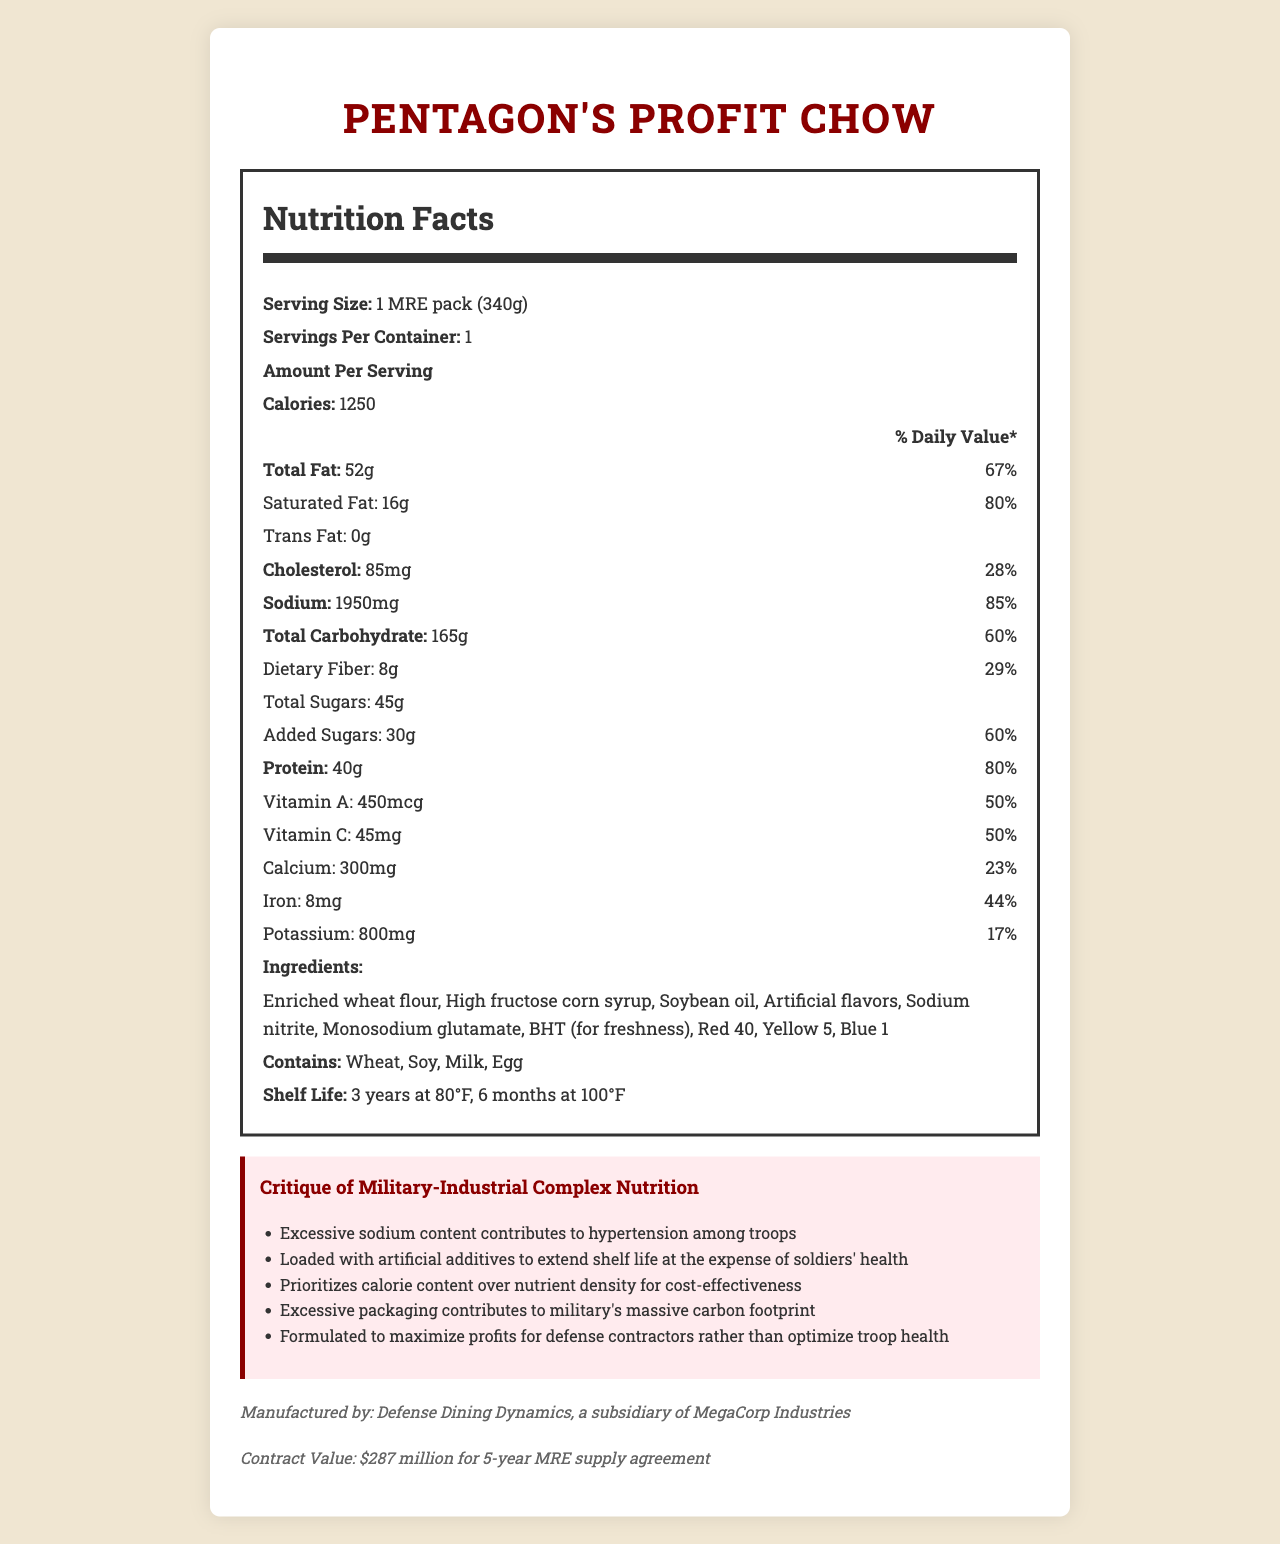what is the serving size for "Pentagon's Profit Chow"? The serving size mentioned in the document is "1 MRE pack (340g)".
Answer: 1 MRE pack (340g) how many calories are in one serving of this MRE? The document states that one serving contains 1250 calories.
Answer: 1250 what is the daily value percentage for saturated fat in one serving? The saturated fat daily value percentage for one serving is listed as 80%.
Answer: 80% list three artificial additives mentioned in the ingredients. The document includes Red 40, Yellow 5, and Blue 1 as artificial additives.
Answer: Red 40, Yellow 5, Blue 1 what is the shelf life of the MRE at 100°F? The MRE's shelf life at 100°F is stated to be 6 months.
Answer: 6 months what is the sodium content in one serving of this MRE? A. 1500 mg B. 2000 mg C. 1950 mg D. 2100 mg The sodium content in one serving is specified as 1950 mg.
Answer: C. 1950 mg which of the following is NOT an allergen in the MRE? 1. Wheat 2. Soy 3. Peanuts 4. Milk The allergens listed in the document are Wheat, Soy, Milk, and Egg. Peanuts are not mentioned.
Answer: 3. Peanuts does this MRE contain any trans fat? The document indicates that the MRE contains 0g of trans fat.
Answer: No what are the main points of critique in the document? The main critique points listed in the document include excessive sodium content, a high amount of artificial additives, priority on calorie content over nutrient density, significant environmental impact due to packaging, and a profit-driven formulation strategy.
Answer: High sodium content, use of artificial additives, poor nutrient density, environmental impact, profit motive. who is the manufacturer of this MRE? The document states that the manufacturer is Defense Dining Dynamics, a subsidiary of MegaCorp Industries.
Answer: Defense Dining Dynamics, a subsidiary of MegaCorp Industries what is the critical issue with the nutrients of this MRE according to the critique? The critique mentions that the MRE prioritizes calorie content over nutrient density.
Answer: Prioritizes calorie content over nutrient density what is the total amount of protein in one serving? The document indicates that one serving of the MRE contains 40g of protein.
Answer: 40g what vitamin has the highest daily value percentage? A. Vitamin A B. Vitamin C C. Calcium D. Iron Vitamin A has a daily value percentage of 50%, which is higher than the other vitamins and minerals listed.
Answer: A. Vitamin A how much does the contract for the MRE supply agreement cost? The document mentions the contract value as $287 million for a 5-year MRE supply agreement.
Answer: $287 million for 5-year MRE supply agreement how many grams of added sugars does this MRE contain? The document lists the added sugars as 30g per serving.
Answer: 30g is the specific formula for the MRE detailed in the document? The document does not provide specific details on the formula for the MRE, only general nutrition facts and ingredients.
Answer: Not enough information what is the overall nutritional profile of this MRE? The nutritional profile reveals that while the MRE is high in calories and protein, it also contains high levels of sodium and fats, coupled with artificial additives, leading to a critique about health and environmental impacts.
Answer: The MRE is high in calories and sodium, has significant amounts of total and saturated fat, and includes artificial additives. It provides substantial amounts of protein, vitamin A, and vitamin C but raises concerns about prioritizing calorie content over nutrient density and environmental impact. 